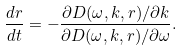<formula> <loc_0><loc_0><loc_500><loc_500>\frac { d r } { d t } = - \frac { \partial D ( \omega , k , r ) / \partial k } { \partial D ( \omega , k , r ) / \partial \omega } .</formula> 